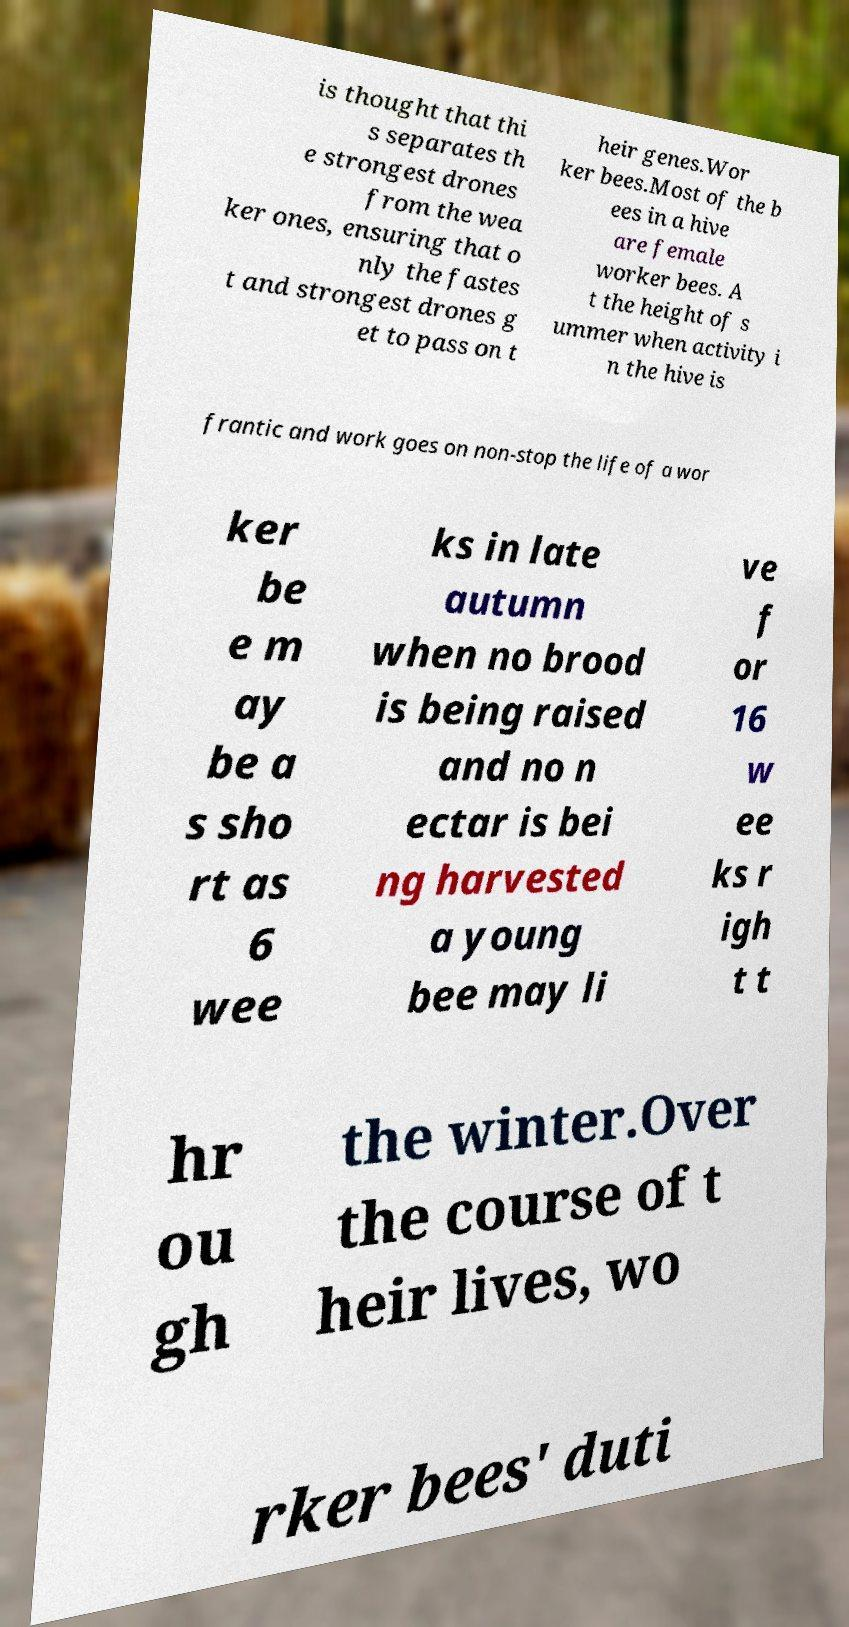Can you accurately transcribe the text from the provided image for me? is thought that thi s separates th e strongest drones from the wea ker ones, ensuring that o nly the fastes t and strongest drones g et to pass on t heir genes.Wor ker bees.Most of the b ees in a hive are female worker bees. A t the height of s ummer when activity i n the hive is frantic and work goes on non-stop the life of a wor ker be e m ay be a s sho rt as 6 wee ks in late autumn when no brood is being raised and no n ectar is bei ng harvested a young bee may li ve f or 16 w ee ks r igh t t hr ou gh the winter.Over the course of t heir lives, wo rker bees' duti 